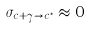<formula> <loc_0><loc_0><loc_500><loc_500>\sigma _ { c + \gamma \rightarrow c ^ { * } } \approx 0</formula> 